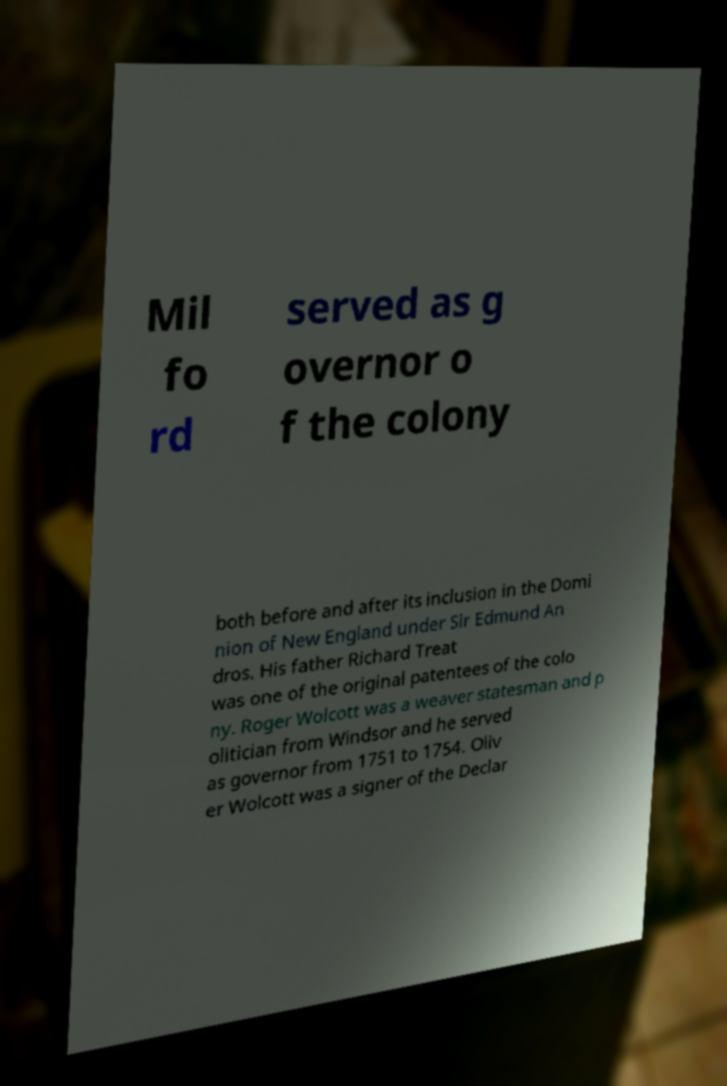For documentation purposes, I need the text within this image transcribed. Could you provide that? Mil fo rd served as g overnor o f the colony both before and after its inclusion in the Domi nion of New England under Sir Edmund An dros. His father Richard Treat was one of the original patentees of the colo ny. Roger Wolcott was a weaver statesman and p olitician from Windsor and he served as governor from 1751 to 1754. Oliv er Wolcott was a signer of the Declar 